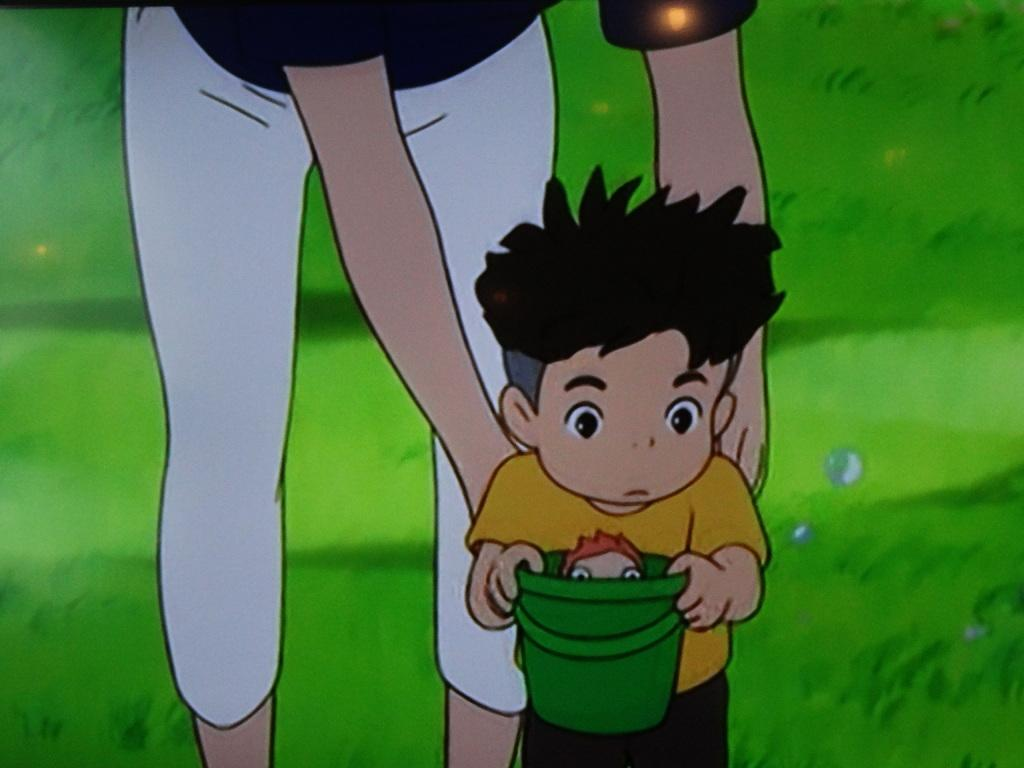What type of characters are depicted in the image? There is a cartoon of a person and a cartoon of a child in the image. What is the child holding in the image? The child is holding a bucket in the image. What is inside the bucket? There is a toy or a person in the bucket. What can be seen in the background of the image? There is grass in the background of the image. Who is the owner of the cartoon person in the image? There is no information about the ownership of the cartoon person in the image. How many women are present in the image? There is no mention of any women in the image; it features a cartoon person and a cartoon child. 